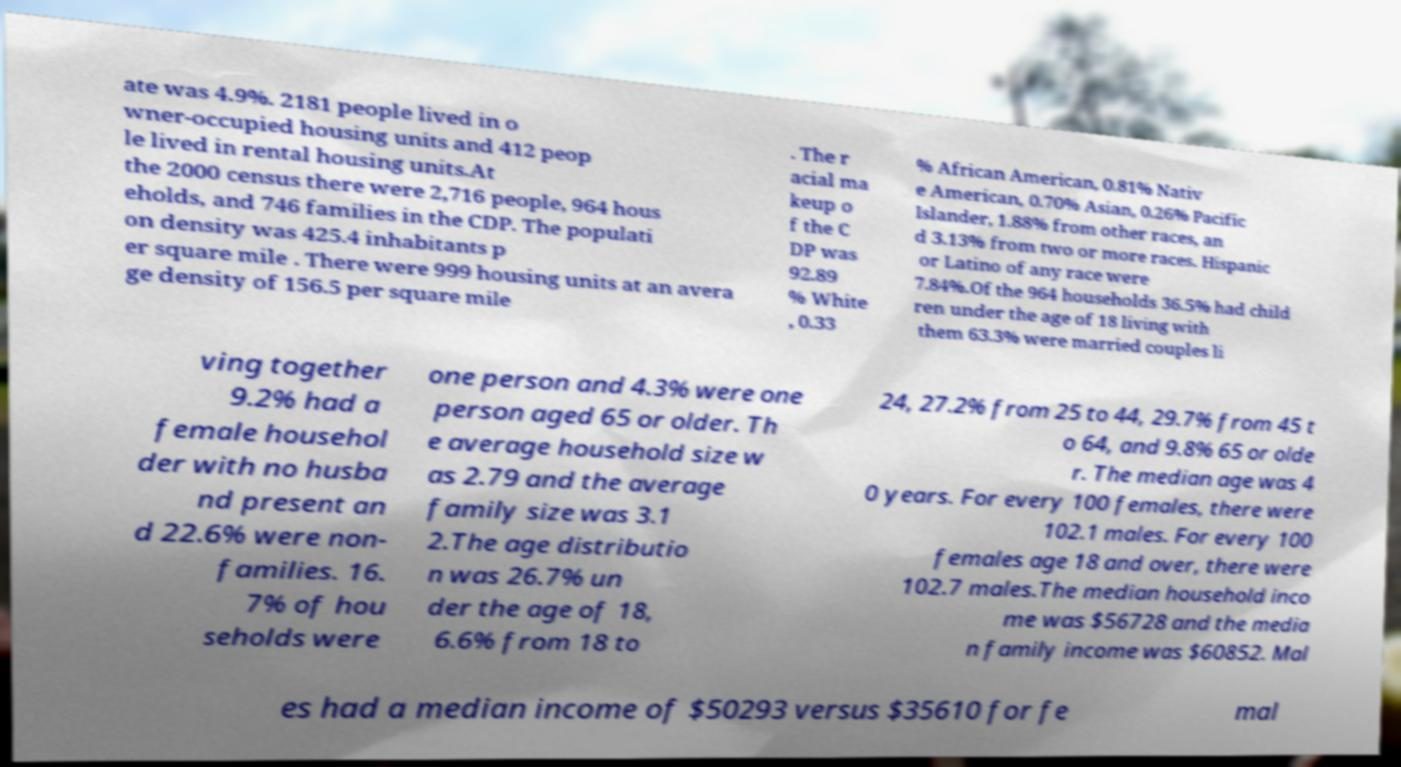I need the written content from this picture converted into text. Can you do that? ate was 4.9%. 2181 people lived in o wner-occupied housing units and 412 peop le lived in rental housing units.At the 2000 census there were 2,716 people, 964 hous eholds, and 746 families in the CDP. The populati on density was 425.4 inhabitants p er square mile . There were 999 housing units at an avera ge density of 156.5 per square mile . The r acial ma keup o f the C DP was 92.89 % White , 0.33 % African American, 0.81% Nativ e American, 0.70% Asian, 0.26% Pacific Islander, 1.88% from other races, an d 3.13% from two or more races. Hispanic or Latino of any race were 7.84%.Of the 964 households 36.5% had child ren under the age of 18 living with them 63.3% were married couples li ving together 9.2% had a female househol der with no husba nd present an d 22.6% were non- families. 16. 7% of hou seholds were one person and 4.3% were one person aged 65 or older. Th e average household size w as 2.79 and the average family size was 3.1 2.The age distributio n was 26.7% un der the age of 18, 6.6% from 18 to 24, 27.2% from 25 to 44, 29.7% from 45 t o 64, and 9.8% 65 or olde r. The median age was 4 0 years. For every 100 females, there were 102.1 males. For every 100 females age 18 and over, there were 102.7 males.The median household inco me was $56728 and the media n family income was $60852. Mal es had a median income of $50293 versus $35610 for fe mal 